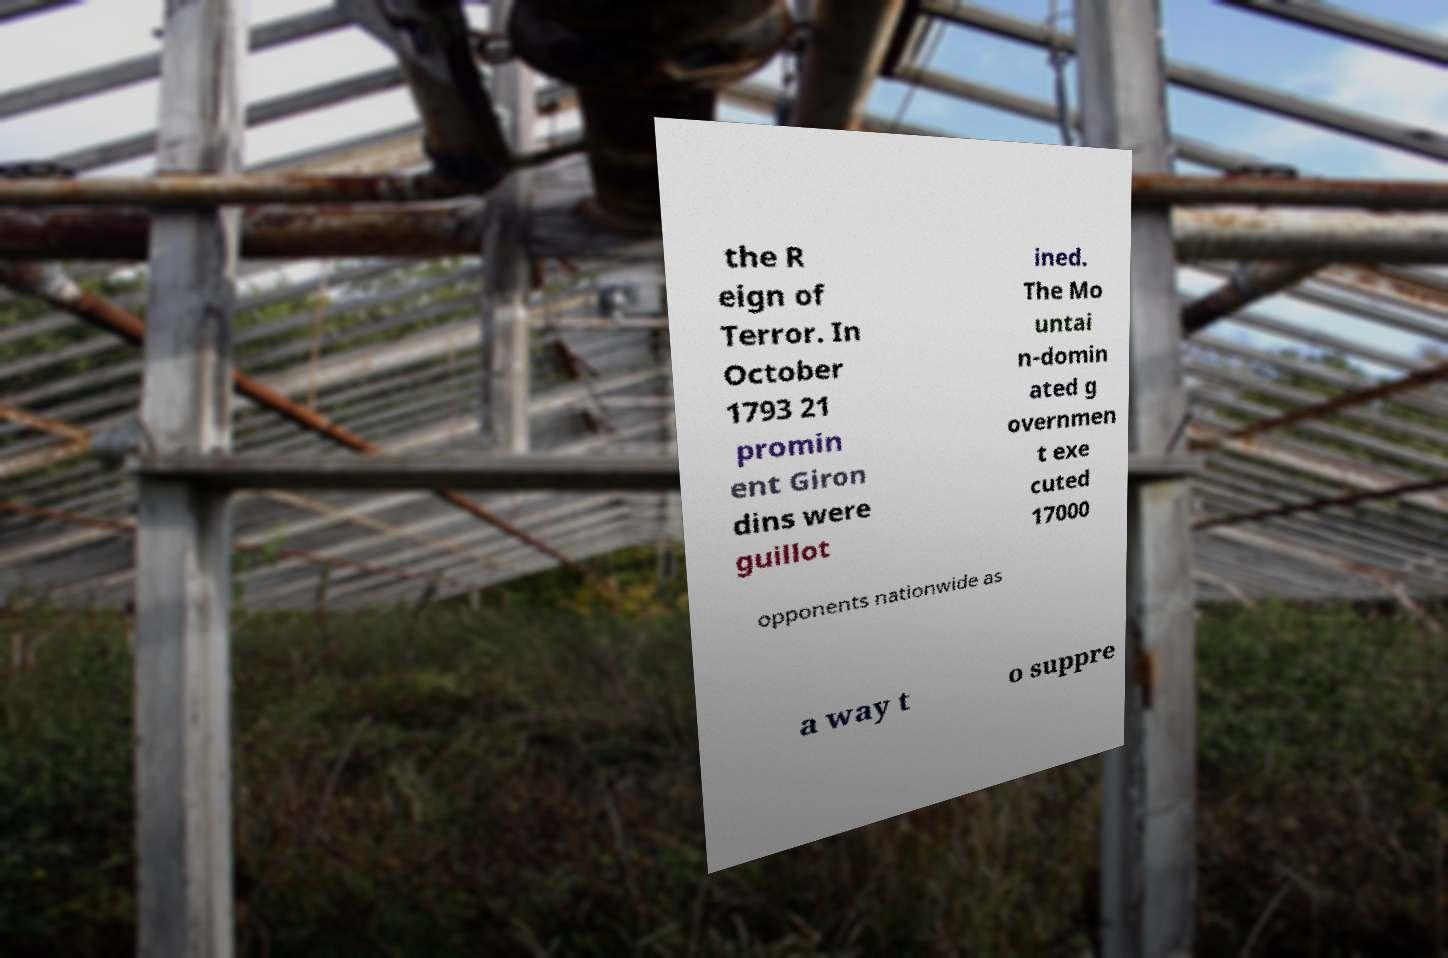Could you assist in decoding the text presented in this image and type it out clearly? the R eign of Terror. In October 1793 21 promin ent Giron dins were guillot ined. The Mo untai n-domin ated g overnmen t exe cuted 17000 opponents nationwide as a way t o suppre 